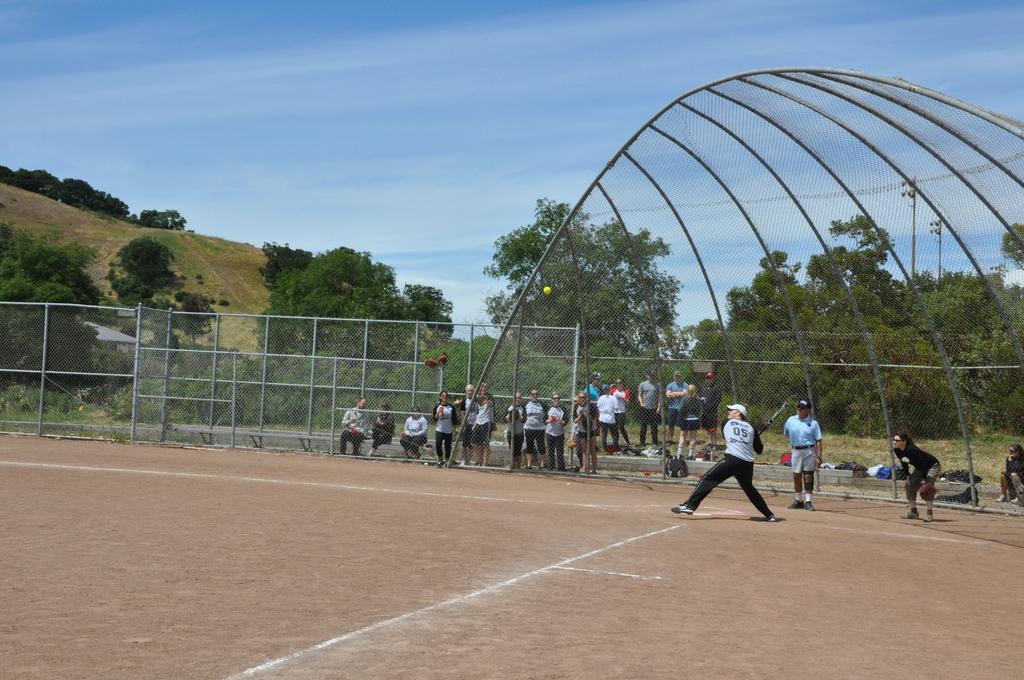What number is batting?
Provide a short and direct response. 05. 